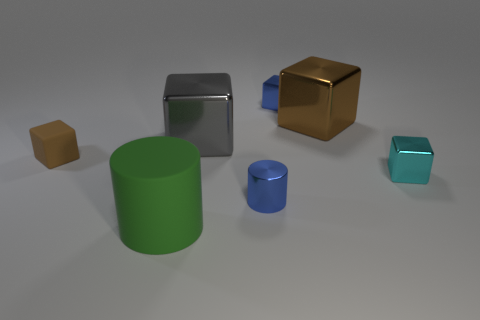If these objects were part of a game, which one would be the most valuable and why? If these objects were part of a game, the golden cube might be deemed the most valuable due to its color, which often signifies wealth or treasure. Its reflective surface and standout color compared to the other objects would likely draw players to it as a valuable item. 